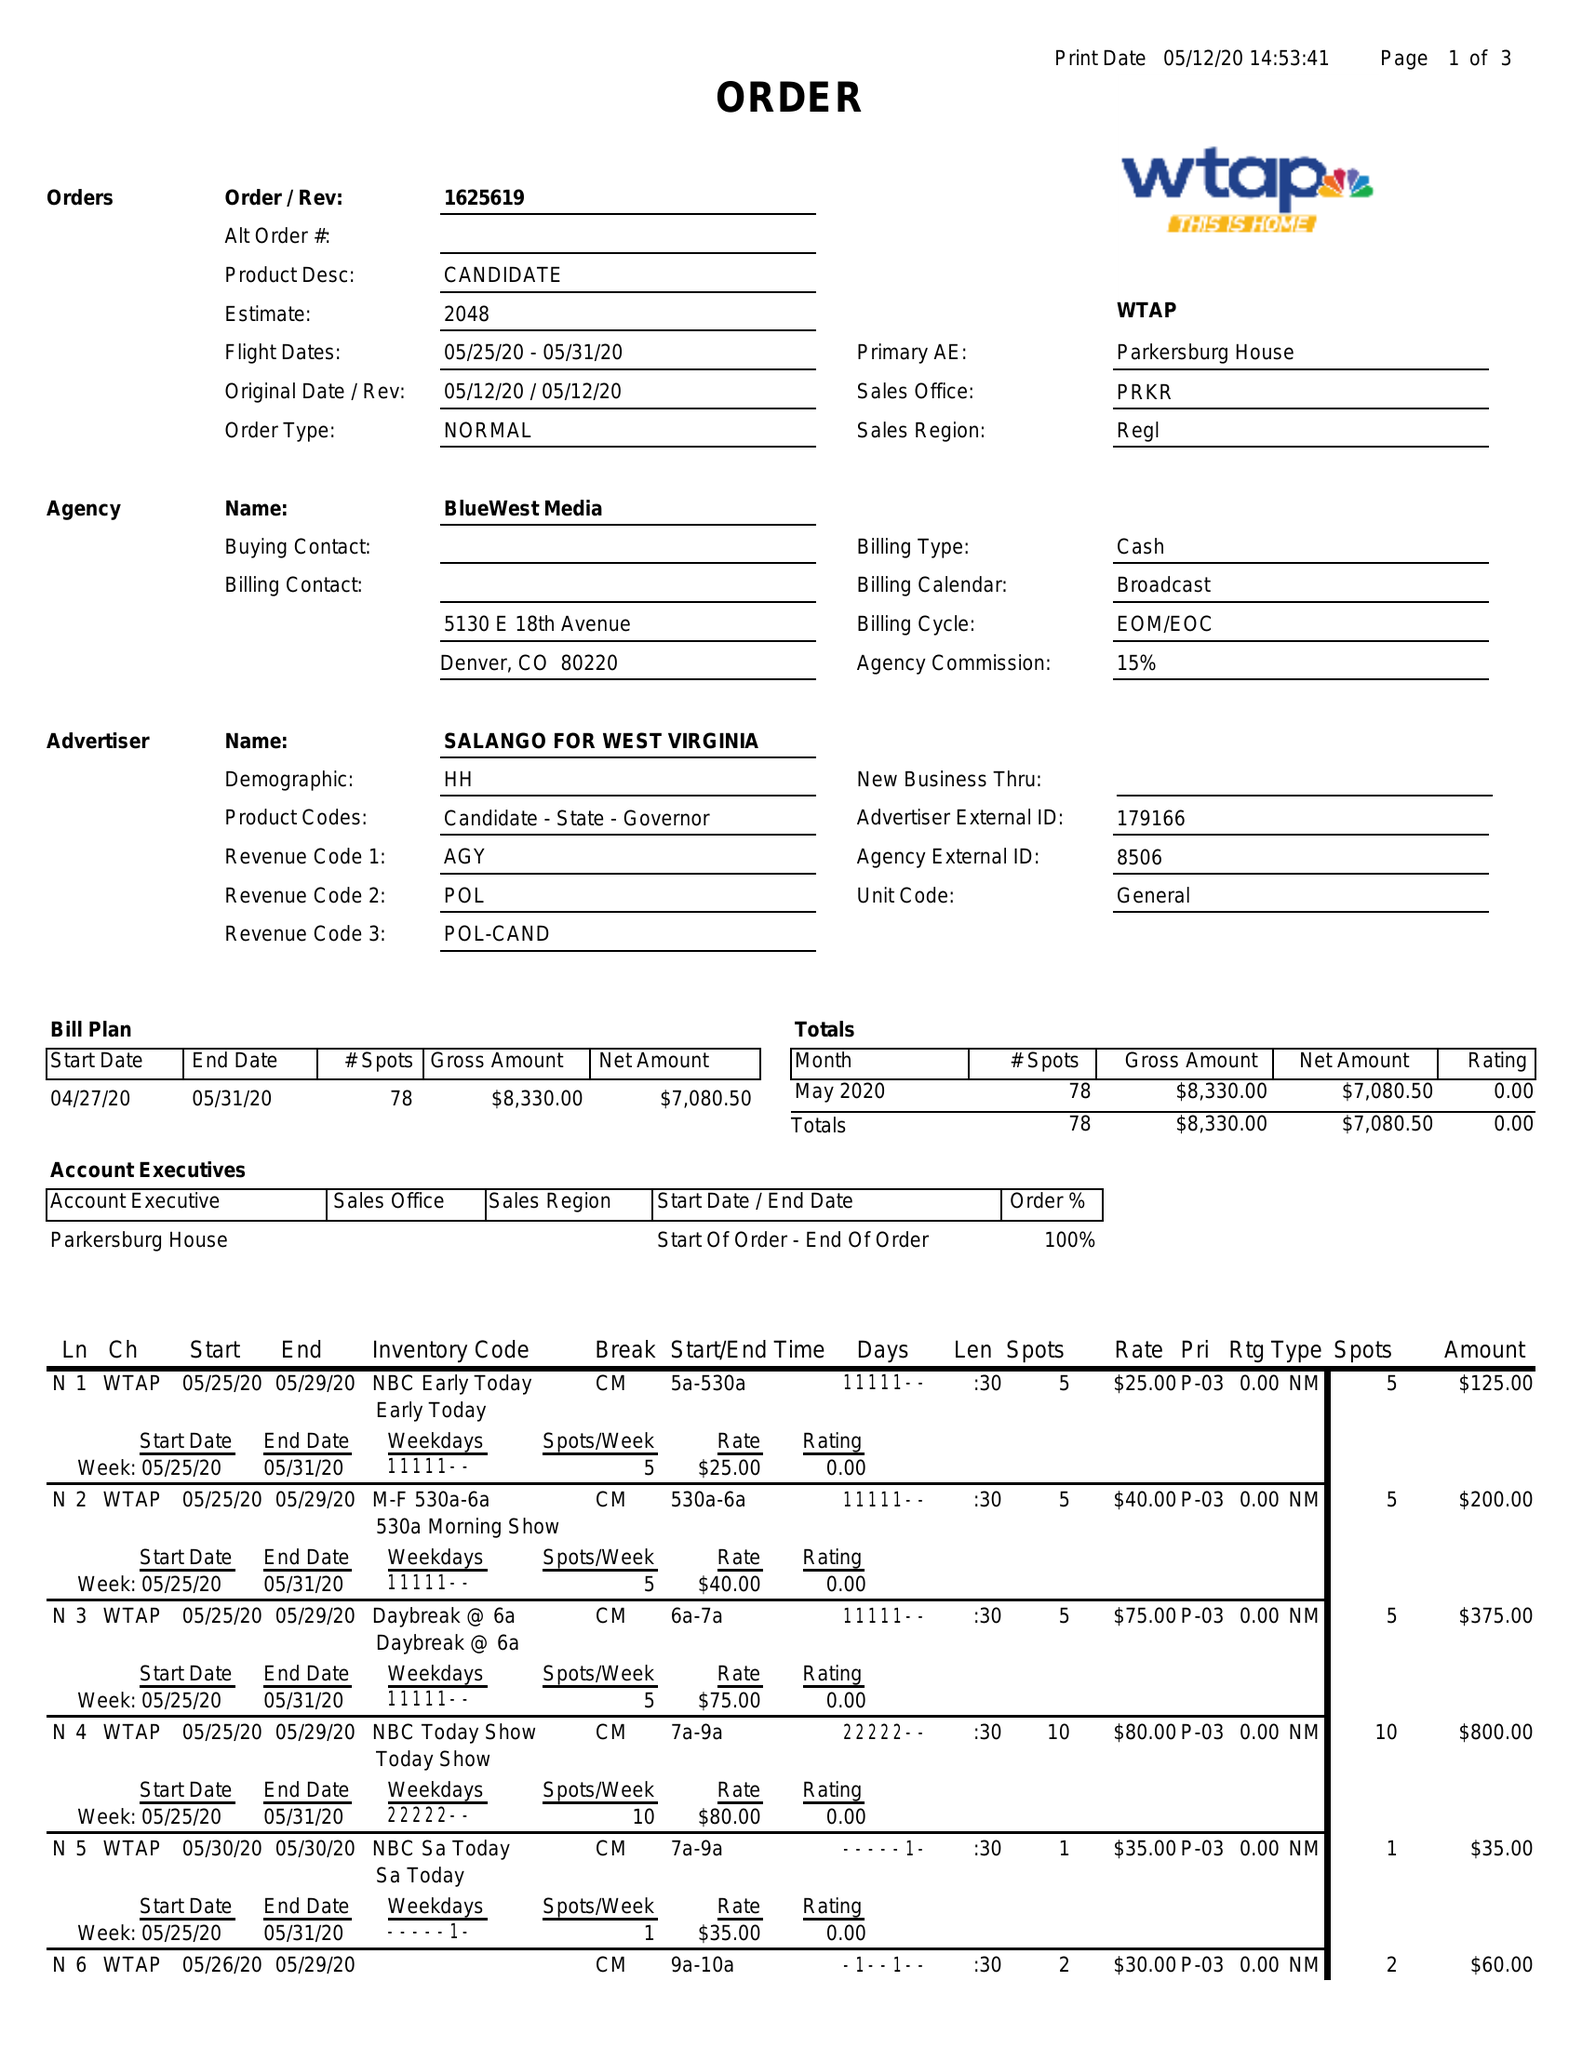What is the value for the advertiser?
Answer the question using a single word or phrase. SALANGO FOR WEST VIRGINIA 